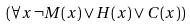<formula> <loc_0><loc_0><loc_500><loc_500>( \forall x \, \neg M ( x ) \lor H ( x ) \lor C ( x ) )</formula> 